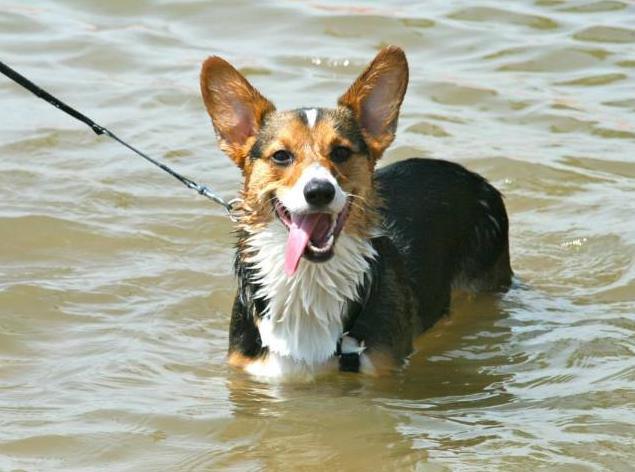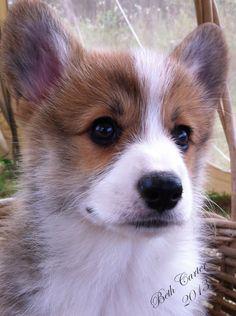The first image is the image on the left, the second image is the image on the right. Analyze the images presented: Is the assertion "The dog in the left photo has a star shapped tag hanging from its collar." valid? Answer yes or no. No. The first image is the image on the left, the second image is the image on the right. Evaluate the accuracy of this statement regarding the images: "One image features a dog wearing a collar with a star-shaped tag.". Is it true? Answer yes or no. No. 